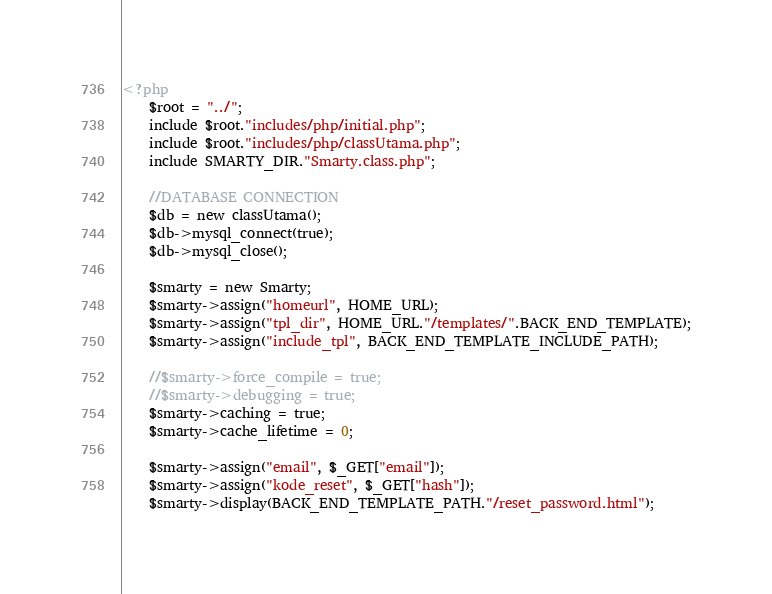Convert code to text. <code><loc_0><loc_0><loc_500><loc_500><_PHP_><?php
    $root = "../";
    include $root."includes/php/initial.php";
    include $root."includes/php/classUtama.php";
    include SMARTY_DIR."Smarty.class.php";
    
    //DATABASE CONNECTION
    $db = new classUtama();
    $db->mysql_connect(true);
    $db->mysql_close();
    
    $smarty = new Smarty;        
    $smarty->assign("homeurl", HOME_URL);
    $smarty->assign("tpl_dir", HOME_URL."/templates/".BACK_END_TEMPLATE);
    $smarty->assign("include_tpl", BACK_END_TEMPLATE_INCLUDE_PATH);
    
    //$smarty->force_compile = true;
    //$smarty->debugging = true;
    $smarty->caching = true;
    $smarty->cache_lifetime = 0;
    
    $smarty->assign("email", $_GET["email"]);
    $smarty->assign("kode_reset", $_GET["hash"]);
    $smarty->display(BACK_END_TEMPLATE_PATH."/reset_password.html");</code> 